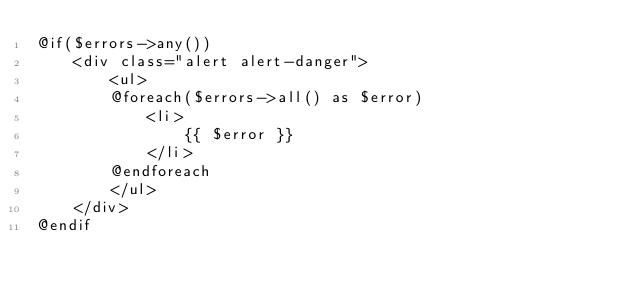Convert code to text. <code><loc_0><loc_0><loc_500><loc_500><_PHP_>@if($errors->any())
    <div class="alert alert-danger">
        <ul>
        @foreach($errors->all() as $error)
            <li>
                {{ $error }}
            </li>
        @endforeach
        </ul>
    </div>
@endif


</code> 